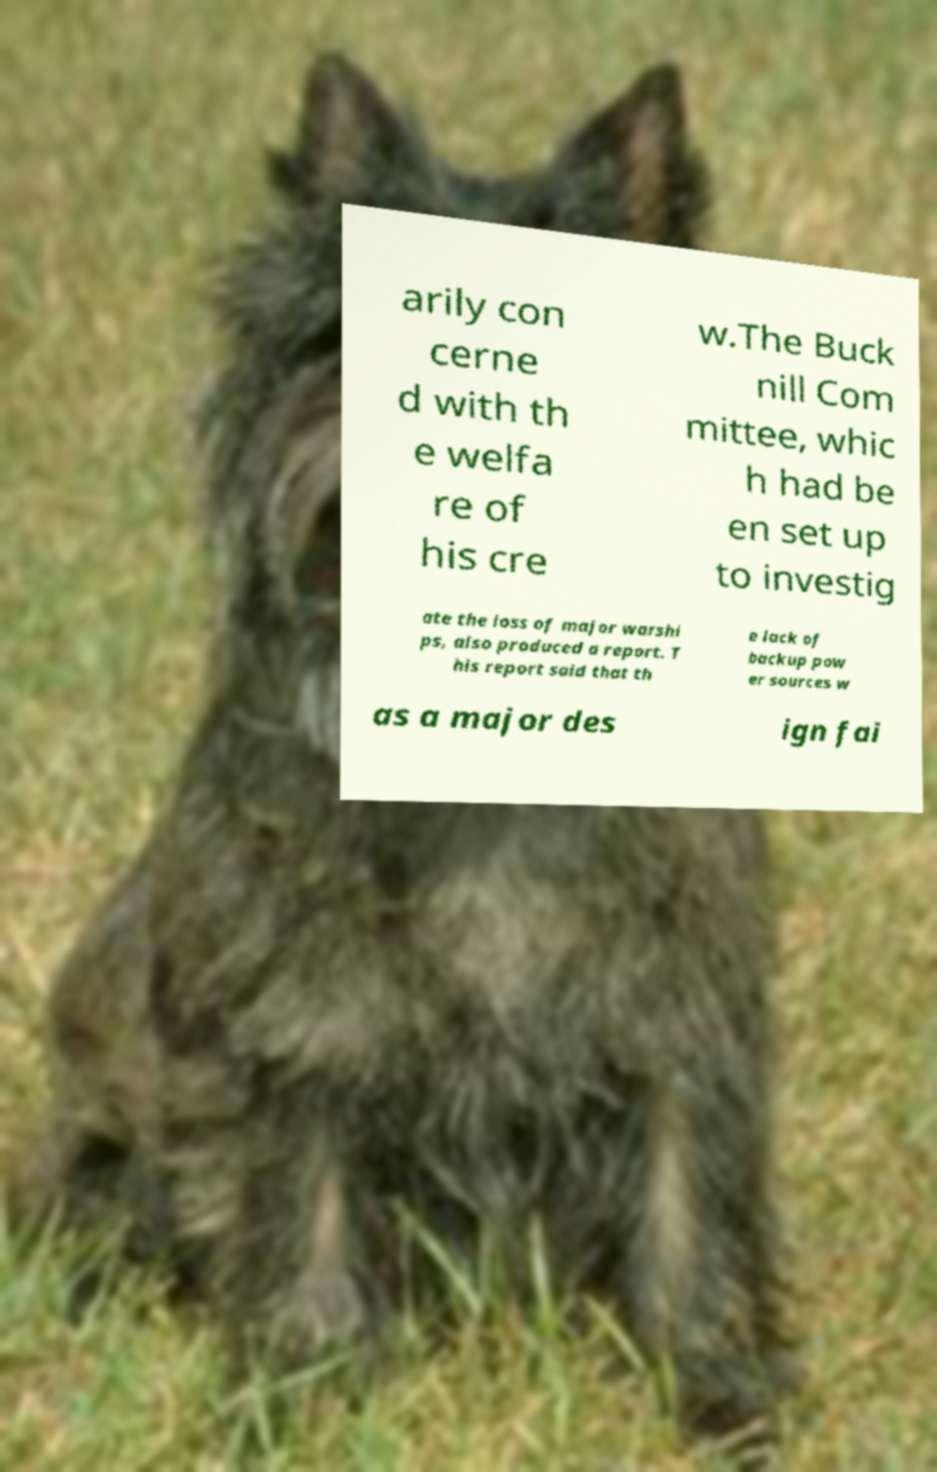Can you accurately transcribe the text from the provided image for me? arily con cerne d with th e welfa re of his cre w.The Buck nill Com mittee, whic h had be en set up to investig ate the loss of major warshi ps, also produced a report. T his report said that th e lack of backup pow er sources w as a major des ign fai 